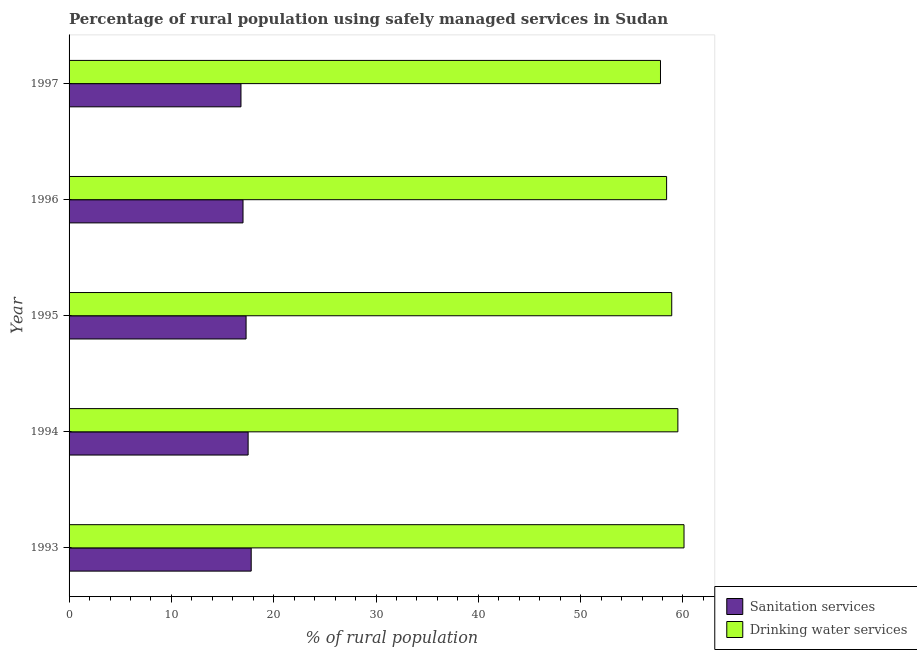How many different coloured bars are there?
Make the answer very short. 2. Are the number of bars on each tick of the Y-axis equal?
Keep it short and to the point. Yes. What is the label of the 2nd group of bars from the top?
Your answer should be very brief. 1996. What is the percentage of rural population who used sanitation services in 1995?
Offer a terse response. 17.3. Across all years, what is the maximum percentage of rural population who used sanitation services?
Provide a short and direct response. 17.8. Across all years, what is the minimum percentage of rural population who used drinking water services?
Your response must be concise. 57.8. In which year was the percentage of rural population who used drinking water services maximum?
Offer a very short reply. 1993. What is the total percentage of rural population who used drinking water services in the graph?
Keep it short and to the point. 294.7. What is the difference between the percentage of rural population who used drinking water services in 1997 and the percentage of rural population who used sanitation services in 1996?
Your answer should be very brief. 40.8. What is the average percentage of rural population who used drinking water services per year?
Provide a succinct answer. 58.94. In the year 1994, what is the difference between the percentage of rural population who used sanitation services and percentage of rural population who used drinking water services?
Your answer should be very brief. -42. In how many years, is the percentage of rural population who used drinking water services greater than 40 %?
Give a very brief answer. 5. Is the difference between the percentage of rural population who used drinking water services in 1995 and 1996 greater than the difference between the percentage of rural population who used sanitation services in 1995 and 1996?
Give a very brief answer. Yes. What is the difference between the highest and the lowest percentage of rural population who used sanitation services?
Offer a very short reply. 1. In how many years, is the percentage of rural population who used drinking water services greater than the average percentage of rural population who used drinking water services taken over all years?
Provide a succinct answer. 2. Is the sum of the percentage of rural population who used drinking water services in 1994 and 1997 greater than the maximum percentage of rural population who used sanitation services across all years?
Provide a succinct answer. Yes. What does the 1st bar from the top in 1993 represents?
Offer a terse response. Drinking water services. What does the 1st bar from the bottom in 1995 represents?
Give a very brief answer. Sanitation services. What is the difference between two consecutive major ticks on the X-axis?
Offer a terse response. 10. Are the values on the major ticks of X-axis written in scientific E-notation?
Your answer should be very brief. No. How many legend labels are there?
Ensure brevity in your answer.  2. How are the legend labels stacked?
Make the answer very short. Vertical. What is the title of the graph?
Give a very brief answer. Percentage of rural population using safely managed services in Sudan. What is the label or title of the X-axis?
Provide a short and direct response. % of rural population. What is the % of rural population in Sanitation services in 1993?
Provide a succinct answer. 17.8. What is the % of rural population in Drinking water services in 1993?
Your answer should be compact. 60.1. What is the % of rural population of Sanitation services in 1994?
Make the answer very short. 17.5. What is the % of rural population of Drinking water services in 1994?
Your response must be concise. 59.5. What is the % of rural population in Sanitation services in 1995?
Your answer should be compact. 17.3. What is the % of rural population of Drinking water services in 1995?
Your answer should be very brief. 58.9. What is the % of rural population in Sanitation services in 1996?
Offer a terse response. 17. What is the % of rural population of Drinking water services in 1996?
Your response must be concise. 58.4. What is the % of rural population of Sanitation services in 1997?
Keep it short and to the point. 16.8. What is the % of rural population in Drinking water services in 1997?
Give a very brief answer. 57.8. Across all years, what is the maximum % of rural population of Drinking water services?
Offer a very short reply. 60.1. Across all years, what is the minimum % of rural population in Drinking water services?
Ensure brevity in your answer.  57.8. What is the total % of rural population in Sanitation services in the graph?
Provide a short and direct response. 86.4. What is the total % of rural population in Drinking water services in the graph?
Your response must be concise. 294.7. What is the difference between the % of rural population in Sanitation services in 1993 and that in 1994?
Keep it short and to the point. 0.3. What is the difference between the % of rural population of Drinking water services in 1993 and that in 1994?
Offer a terse response. 0.6. What is the difference between the % of rural population of Sanitation services in 1993 and that in 1995?
Make the answer very short. 0.5. What is the difference between the % of rural population of Drinking water services in 1993 and that in 1995?
Your answer should be very brief. 1.2. What is the difference between the % of rural population in Drinking water services in 1993 and that in 1996?
Make the answer very short. 1.7. What is the difference between the % of rural population in Sanitation services in 1993 and that in 1997?
Keep it short and to the point. 1. What is the difference between the % of rural population in Drinking water services in 1993 and that in 1997?
Ensure brevity in your answer.  2.3. What is the difference between the % of rural population of Sanitation services in 1994 and that in 1995?
Your answer should be very brief. 0.2. What is the difference between the % of rural population of Sanitation services in 1994 and that in 1996?
Keep it short and to the point. 0.5. What is the difference between the % of rural population in Sanitation services in 1995 and that in 1996?
Your response must be concise. 0.3. What is the difference between the % of rural population in Sanitation services in 1995 and that in 1997?
Provide a succinct answer. 0.5. What is the difference between the % of rural population in Sanitation services in 1996 and that in 1997?
Your response must be concise. 0.2. What is the difference between the % of rural population in Drinking water services in 1996 and that in 1997?
Ensure brevity in your answer.  0.6. What is the difference between the % of rural population of Sanitation services in 1993 and the % of rural population of Drinking water services in 1994?
Offer a very short reply. -41.7. What is the difference between the % of rural population of Sanitation services in 1993 and the % of rural population of Drinking water services in 1995?
Your answer should be compact. -41.1. What is the difference between the % of rural population in Sanitation services in 1993 and the % of rural population in Drinking water services in 1996?
Keep it short and to the point. -40.6. What is the difference between the % of rural population of Sanitation services in 1993 and the % of rural population of Drinking water services in 1997?
Offer a very short reply. -40. What is the difference between the % of rural population of Sanitation services in 1994 and the % of rural population of Drinking water services in 1995?
Provide a succinct answer. -41.4. What is the difference between the % of rural population of Sanitation services in 1994 and the % of rural population of Drinking water services in 1996?
Ensure brevity in your answer.  -40.9. What is the difference between the % of rural population in Sanitation services in 1994 and the % of rural population in Drinking water services in 1997?
Provide a short and direct response. -40.3. What is the difference between the % of rural population in Sanitation services in 1995 and the % of rural population in Drinking water services in 1996?
Keep it short and to the point. -41.1. What is the difference between the % of rural population of Sanitation services in 1995 and the % of rural population of Drinking water services in 1997?
Provide a succinct answer. -40.5. What is the difference between the % of rural population in Sanitation services in 1996 and the % of rural population in Drinking water services in 1997?
Offer a terse response. -40.8. What is the average % of rural population in Sanitation services per year?
Your answer should be very brief. 17.28. What is the average % of rural population in Drinking water services per year?
Your response must be concise. 58.94. In the year 1993, what is the difference between the % of rural population in Sanitation services and % of rural population in Drinking water services?
Your answer should be compact. -42.3. In the year 1994, what is the difference between the % of rural population of Sanitation services and % of rural population of Drinking water services?
Make the answer very short. -42. In the year 1995, what is the difference between the % of rural population in Sanitation services and % of rural population in Drinking water services?
Offer a terse response. -41.6. In the year 1996, what is the difference between the % of rural population in Sanitation services and % of rural population in Drinking water services?
Your answer should be compact. -41.4. In the year 1997, what is the difference between the % of rural population of Sanitation services and % of rural population of Drinking water services?
Offer a very short reply. -41. What is the ratio of the % of rural population of Sanitation services in 1993 to that in 1994?
Give a very brief answer. 1.02. What is the ratio of the % of rural population in Drinking water services in 1993 to that in 1994?
Provide a short and direct response. 1.01. What is the ratio of the % of rural population of Sanitation services in 1993 to that in 1995?
Give a very brief answer. 1.03. What is the ratio of the % of rural population in Drinking water services in 1993 to that in 1995?
Your answer should be compact. 1.02. What is the ratio of the % of rural population in Sanitation services in 1993 to that in 1996?
Ensure brevity in your answer.  1.05. What is the ratio of the % of rural population in Drinking water services in 1993 to that in 1996?
Your response must be concise. 1.03. What is the ratio of the % of rural population in Sanitation services in 1993 to that in 1997?
Keep it short and to the point. 1.06. What is the ratio of the % of rural population in Drinking water services in 1993 to that in 1997?
Offer a very short reply. 1.04. What is the ratio of the % of rural population of Sanitation services in 1994 to that in 1995?
Keep it short and to the point. 1.01. What is the ratio of the % of rural population of Drinking water services in 1994 to that in 1995?
Ensure brevity in your answer.  1.01. What is the ratio of the % of rural population of Sanitation services in 1994 to that in 1996?
Your response must be concise. 1.03. What is the ratio of the % of rural population of Drinking water services in 1994 to that in 1996?
Give a very brief answer. 1.02. What is the ratio of the % of rural population in Sanitation services in 1994 to that in 1997?
Ensure brevity in your answer.  1.04. What is the ratio of the % of rural population in Drinking water services in 1994 to that in 1997?
Offer a very short reply. 1.03. What is the ratio of the % of rural population of Sanitation services in 1995 to that in 1996?
Your answer should be compact. 1.02. What is the ratio of the % of rural population of Drinking water services in 1995 to that in 1996?
Your response must be concise. 1.01. What is the ratio of the % of rural population in Sanitation services in 1995 to that in 1997?
Provide a short and direct response. 1.03. What is the ratio of the % of rural population of Drinking water services in 1995 to that in 1997?
Provide a succinct answer. 1.02. What is the ratio of the % of rural population of Sanitation services in 1996 to that in 1997?
Offer a terse response. 1.01. What is the ratio of the % of rural population of Drinking water services in 1996 to that in 1997?
Ensure brevity in your answer.  1.01. 